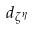<formula> <loc_0><loc_0><loc_500><loc_500>d _ { \zeta ^ { \eta } }</formula> 